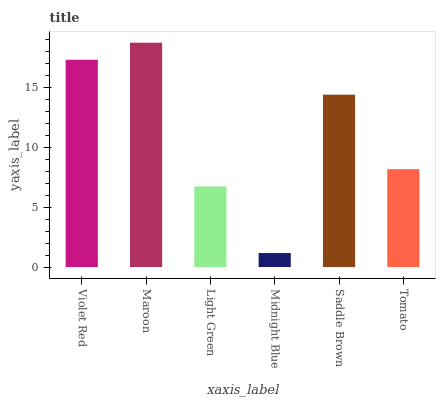Is Midnight Blue the minimum?
Answer yes or no. Yes. Is Maroon the maximum?
Answer yes or no. Yes. Is Light Green the minimum?
Answer yes or no. No. Is Light Green the maximum?
Answer yes or no. No. Is Maroon greater than Light Green?
Answer yes or no. Yes. Is Light Green less than Maroon?
Answer yes or no. Yes. Is Light Green greater than Maroon?
Answer yes or no. No. Is Maroon less than Light Green?
Answer yes or no. No. Is Saddle Brown the high median?
Answer yes or no. Yes. Is Tomato the low median?
Answer yes or no. Yes. Is Maroon the high median?
Answer yes or no. No. Is Violet Red the low median?
Answer yes or no. No. 